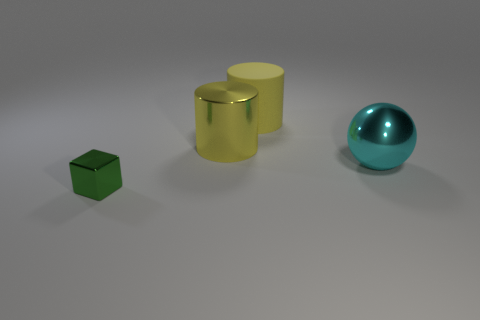Are there any purple rubber things of the same size as the metallic block?
Ensure brevity in your answer.  No. What shape is the big metallic object that is the same color as the matte cylinder?
Your answer should be very brief. Cylinder. How many yellow metallic things are the same size as the sphere?
Offer a very short reply. 1. Does the yellow metal cylinder behind the cyan sphere have the same size as the yellow matte object to the right of the large yellow shiny object?
Keep it short and to the point. Yes. What number of things are big cyan spheres or metal things that are to the right of the tiny green metal object?
Your answer should be very brief. 2. What is the color of the matte cylinder?
Offer a very short reply. Yellow. What material is the object in front of the large thing in front of the large yellow cylinder that is in front of the large yellow matte thing?
Ensure brevity in your answer.  Metal. What size is the cyan thing that is made of the same material as the green object?
Ensure brevity in your answer.  Large. Is there another large shiny sphere of the same color as the big metallic ball?
Your response must be concise. No. Does the sphere have the same size as the object that is in front of the cyan thing?
Make the answer very short. No. 